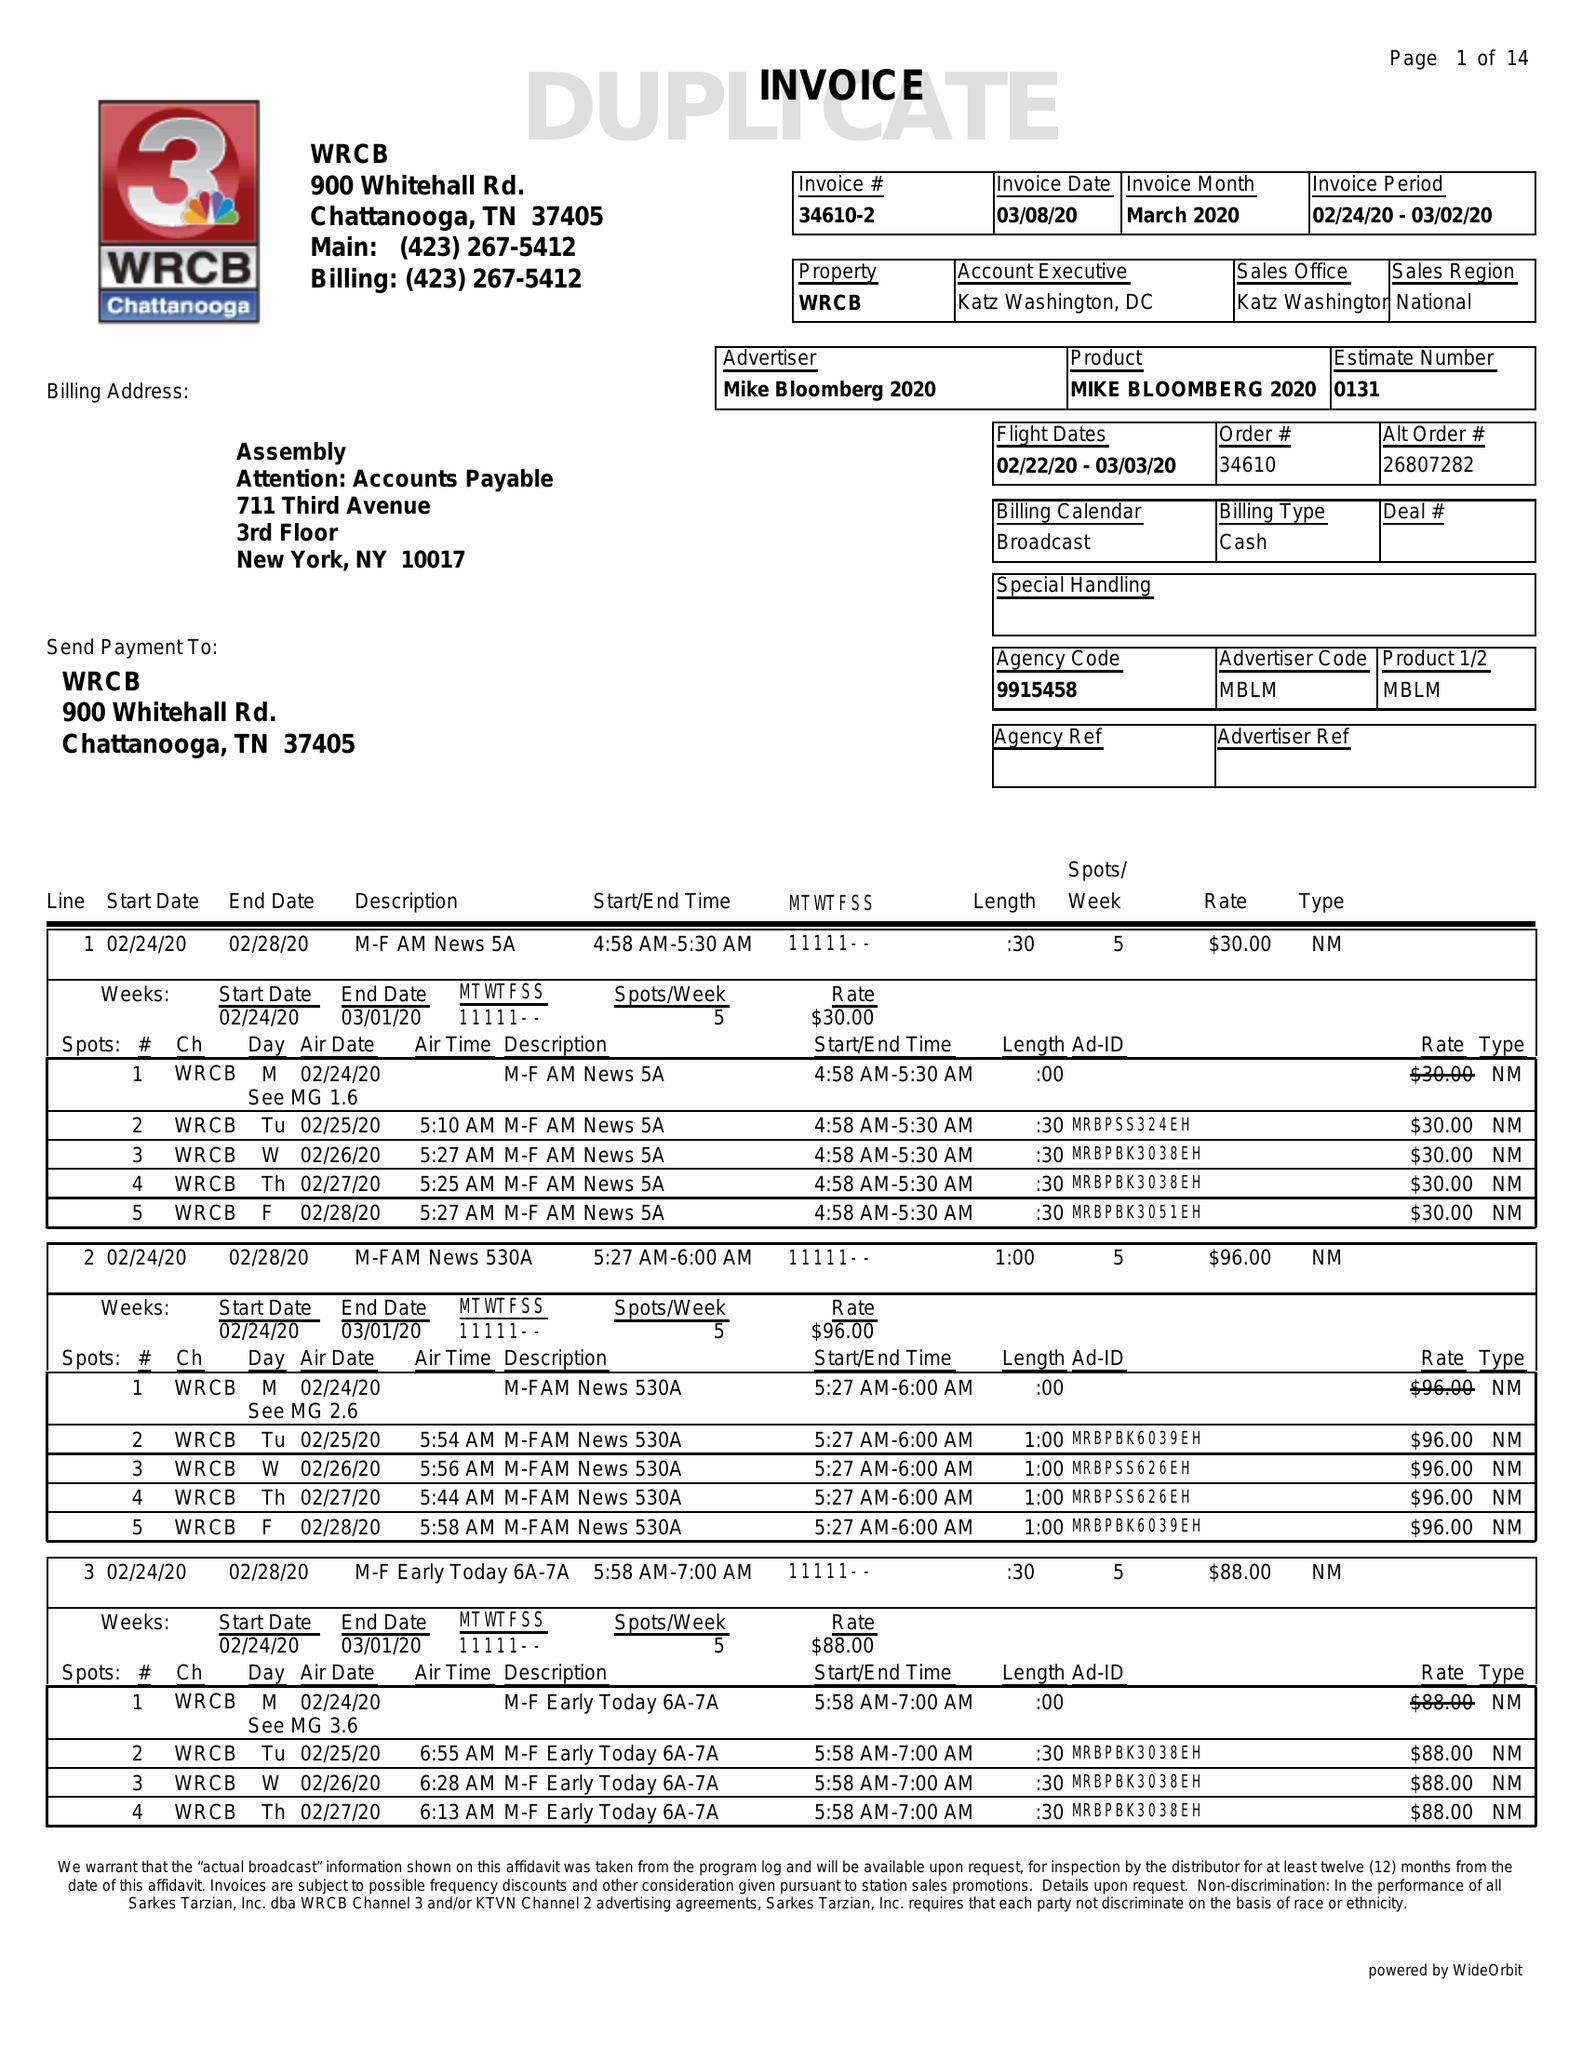What is the value for the advertiser?
Answer the question using a single word or phrase. MIKE BLOOMBERG 2020 